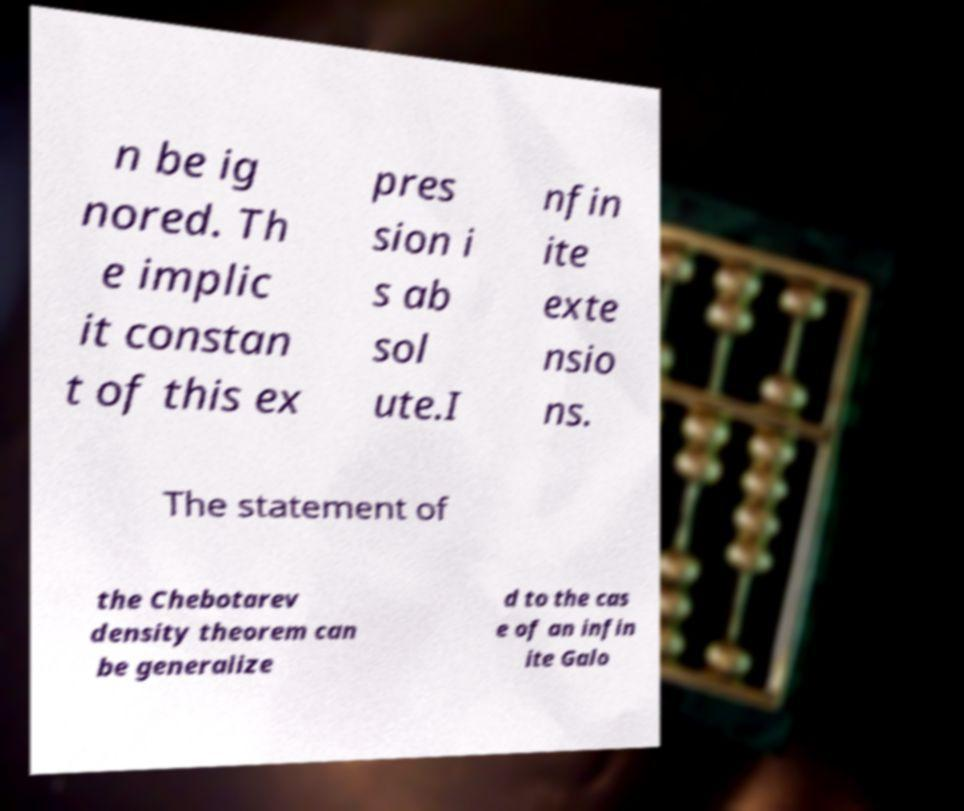Can you read and provide the text displayed in the image?This photo seems to have some interesting text. Can you extract and type it out for me? n be ig nored. Th e implic it constan t of this ex pres sion i s ab sol ute.I nfin ite exte nsio ns. The statement of the Chebotarev density theorem can be generalize d to the cas e of an infin ite Galo 